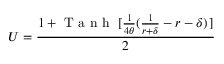<formula> <loc_0><loc_0><loc_500><loc_500>U = \frac { 1 + T a n h [ \frac { 1 } { 4 \theta } ( \frac { 1 } { r + \delta } - r - \delta ) ] } { 2 }</formula> 